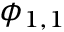Convert formula to latex. <formula><loc_0><loc_0><loc_500><loc_500>\phi _ { 1 , 1 }</formula> 